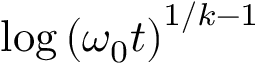Convert formula to latex. <formula><loc_0><loc_0><loc_500><loc_500>\log \left ( \omega _ { 0 } t \right ) ^ { 1 / k - 1 }</formula> 